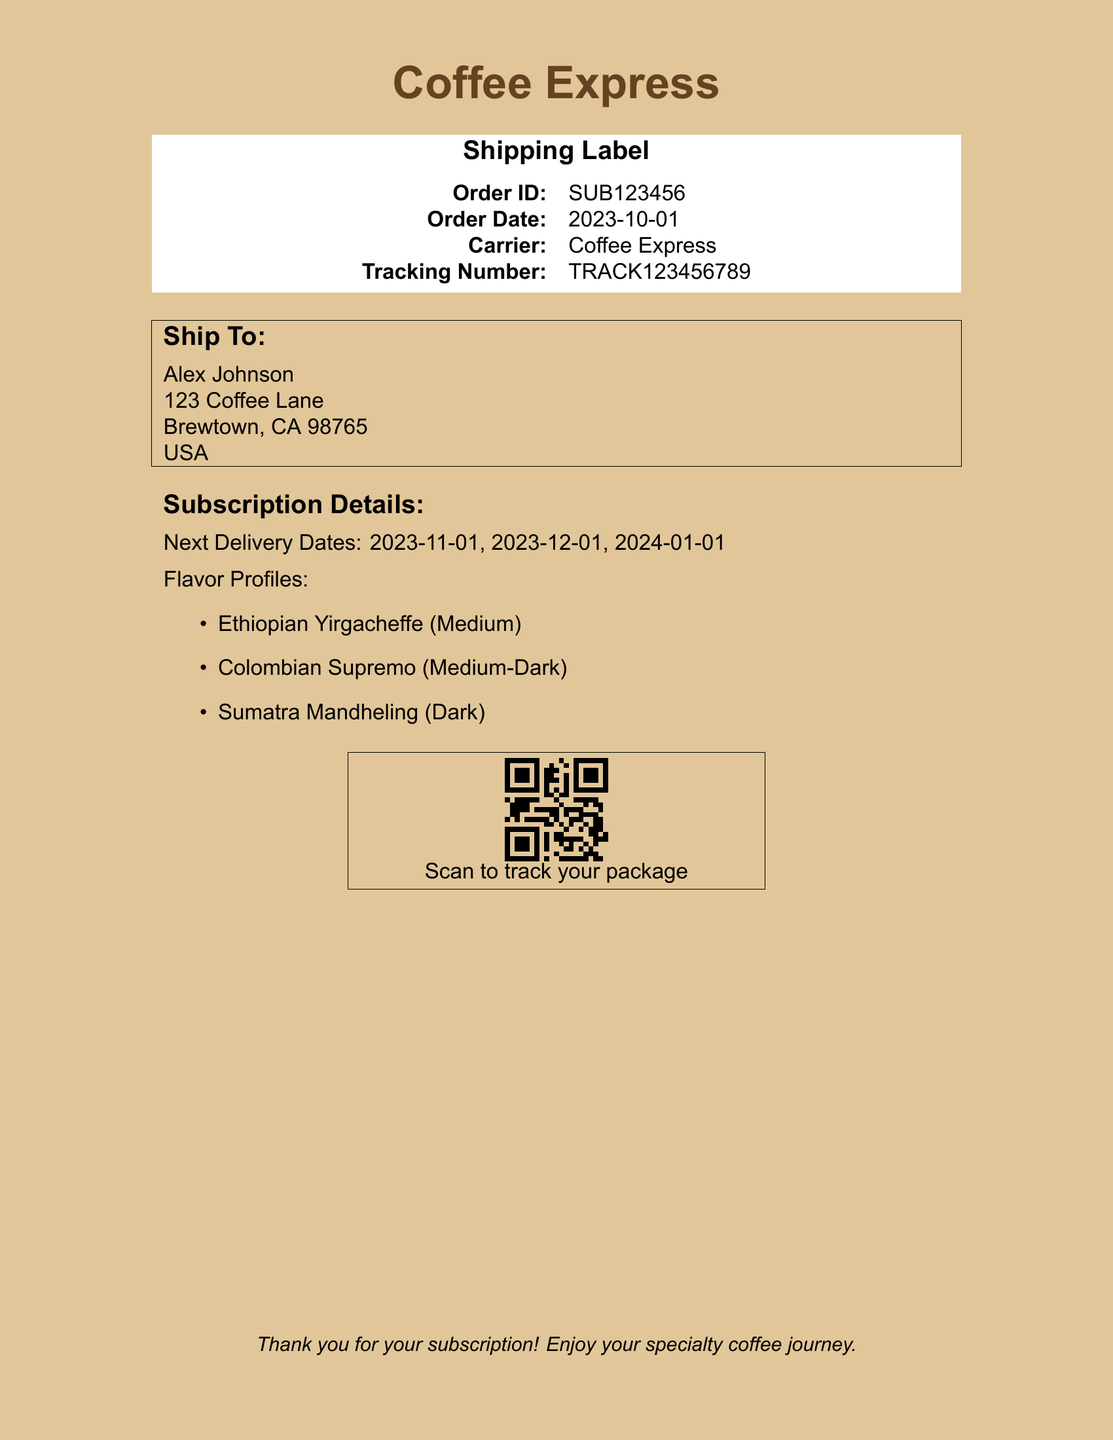what is the Order ID? The Order ID is mentioned in the document as part of the shipping label details.
Answer: SUB123456 what is the Order Date? The Order Date is stated near the Order ID in the shipping label.
Answer: 2023-10-01 who is the recipient of the package? The recipient's name is located under the "Ship To" section.
Answer: Alex Johnson what are the next delivery dates? The next delivery dates are listed in the Subscription Details section.
Answer: 2023-11-01, 2023-12-01, 2024-01-01 how many flavor profiles are listed? The flavor profiles section contains multiple items listing different types of coffee.
Answer: 3 what is the last flavor profile mentioned? The last flavor profile is at the bottom of the flavor list in the document.
Answer: Sumatra Mandheling (Dark) what is the carrier used for shipping? The carrier's name is specified in the shipping label section.
Answer: Coffee Express how can I track my package? The method to track the package is indicated by the presence of a QR code.
Answer: Scan QR code what is the tracking number? The tracking number is provided in the shipping label details.
Answer: TRACK123456789 